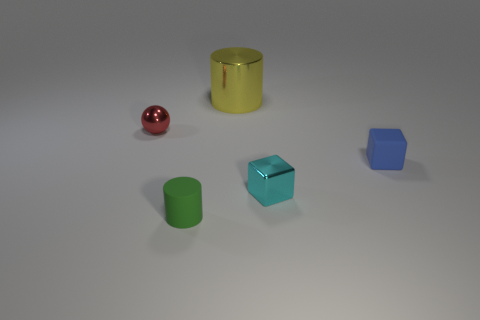Is the number of blocks on the left side of the tiny blue rubber block greater than the number of blue objects?
Give a very brief answer. No. There is another matte thing that is the same size as the green thing; what is its color?
Provide a succinct answer. Blue. How many objects are either matte cylinders to the right of the ball or small cyan cubes?
Your answer should be compact. 2. What is the material of the object in front of the metal thing right of the yellow object?
Provide a succinct answer. Rubber. Are there any red spheres made of the same material as the tiny red object?
Your answer should be compact. No. There is a tiny matte thing that is left of the big yellow cylinder; are there any green cylinders to the right of it?
Give a very brief answer. No. What material is the cylinder behind the small cylinder?
Give a very brief answer. Metal. Do the small blue matte object and the big thing have the same shape?
Offer a terse response. No. There is a matte thing that is left of the cylinder behind the blue matte block to the right of the large yellow shiny cylinder; what color is it?
Offer a very short reply. Green. How many yellow things have the same shape as the tiny red metallic object?
Keep it short and to the point. 0. 